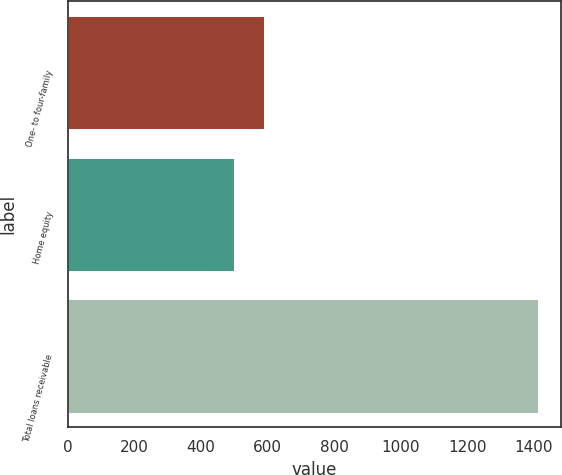Convert chart. <chart><loc_0><loc_0><loc_500><loc_500><bar_chart><fcel>One- to four-family<fcel>Home equity<fcel>Total loans receivable<nl><fcel>589.4<fcel>498<fcel>1412<nl></chart> 